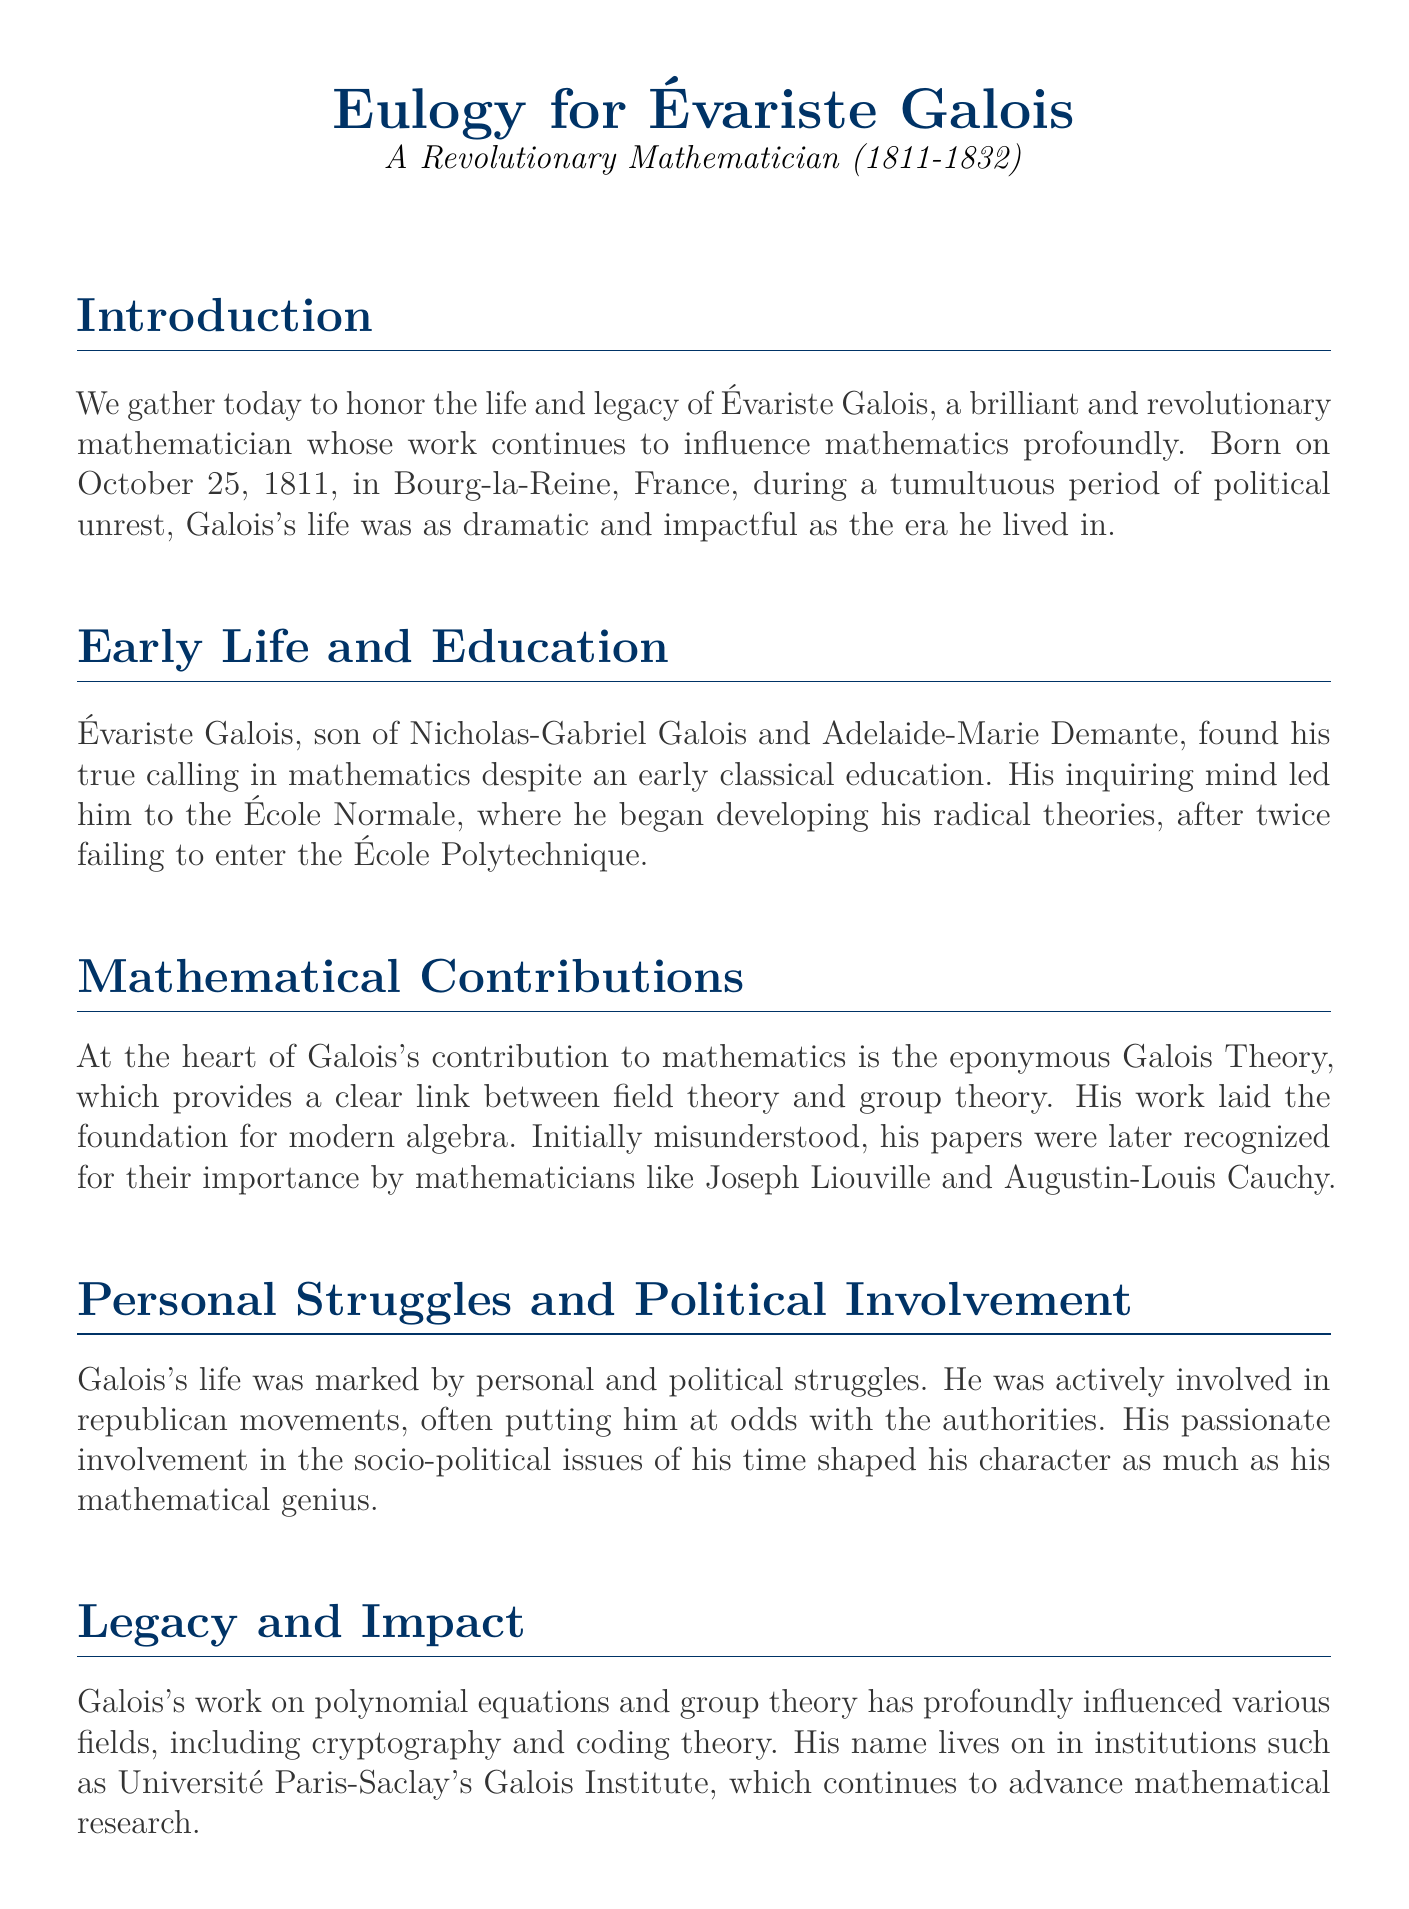What is the birth date of Évariste Galois? The document provides specific information about Évariste Galois's birth date, which is October 25, 1811.
Answer: October 25, 1811 What is the title of the document? The title of the eulogy is highlighted at the beginning of the document, which is "Eulogy for Évariste Galois."
Answer: Eulogy for Évariste Galois Who recognized Galois's work for its importance? The document states that Galois's papers were later recognized by mathematicians like Joseph Liouville and Augustin-Louis Cauchy.
Answer: Joseph Liouville and Augustin-Louis Cauchy What age was Galois when he died? The document mentions that Galois’s life was tragically cut short at the age of 20.
Answer: 20 What concept is at the heart of Galois's contribution? The document specifies that Galois's contribution to mathematics centers around Galois Theory.
Answer: Galois Theory Why was Galois's life marked by struggles? The text indicates that Galois was actively involved in republican movements, often putting him at odds with the authorities.
Answer: Republican movements What institute is named after Galois? The document mentions the Université Paris-Saclay's Galois Institute, which continues to advance mathematical research.
Answer: Galois Institute What was Galois's primary field of study? The document emphasizes that Galois found his true calling in mathematics.
Answer: Mathematics How did Galois's life influence future generations? The eulogy notes that Galois continues to inspire new generations of mathematicians and scientists.
Answer: Inspire new generations 